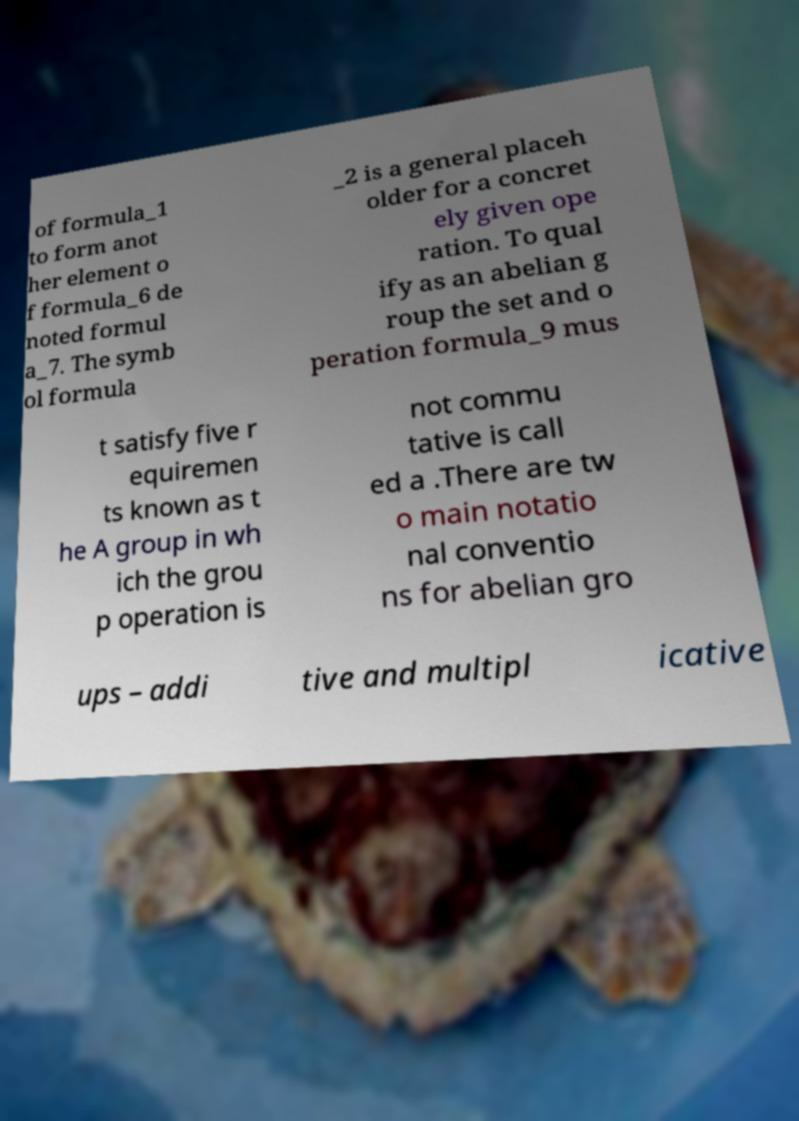Could you extract and type out the text from this image? of formula_1 to form anot her element o f formula_6 de noted formul a_7. The symb ol formula _2 is a general placeh older for a concret ely given ope ration. To qual ify as an abelian g roup the set and o peration formula_9 mus t satisfy five r equiremen ts known as t he A group in wh ich the grou p operation is not commu tative is call ed a .There are tw o main notatio nal conventio ns for abelian gro ups – addi tive and multipl icative 